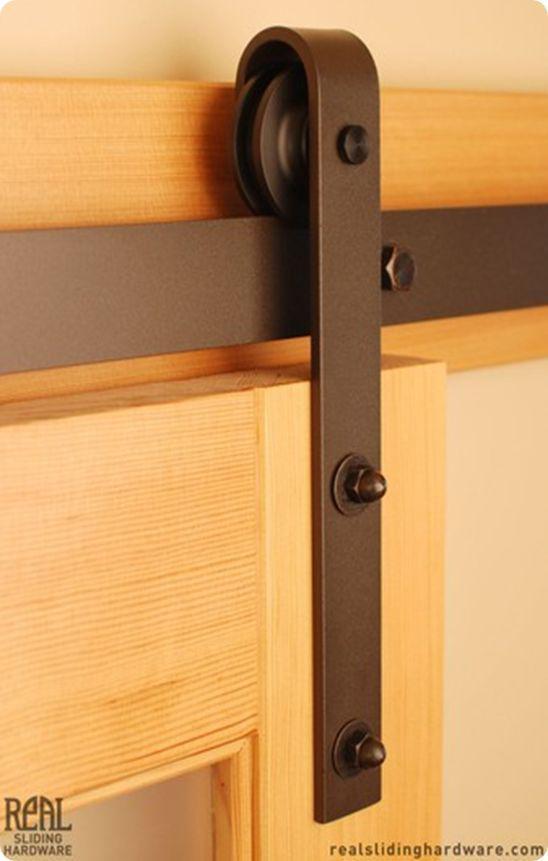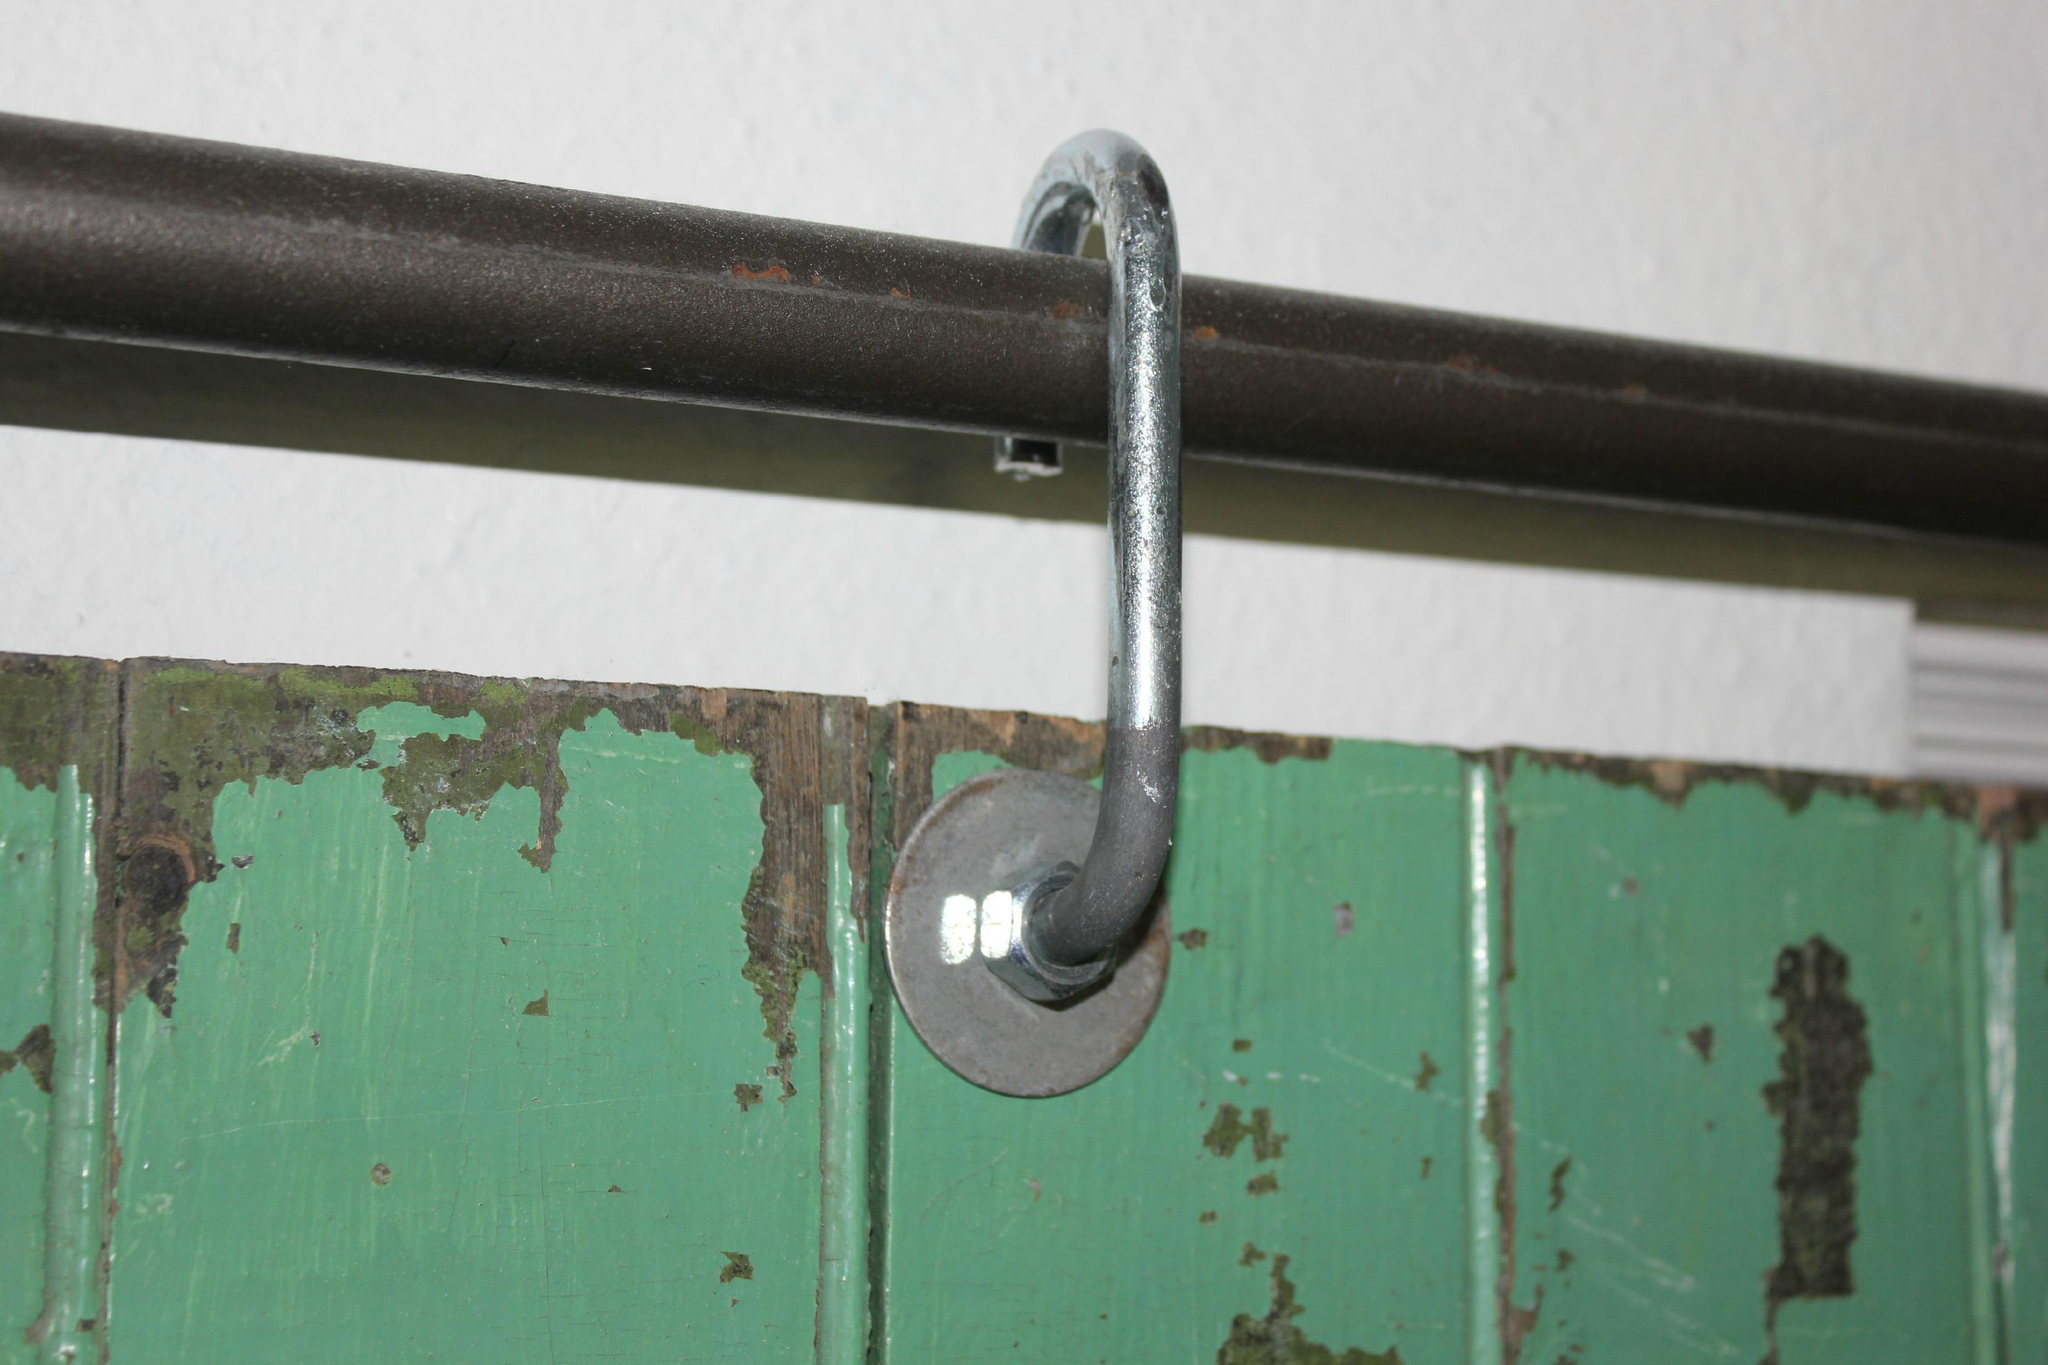The first image is the image on the left, the second image is the image on the right. For the images shown, is this caption "The door section shown in the left image is not displayed at an angle." true? Answer yes or no. No. 